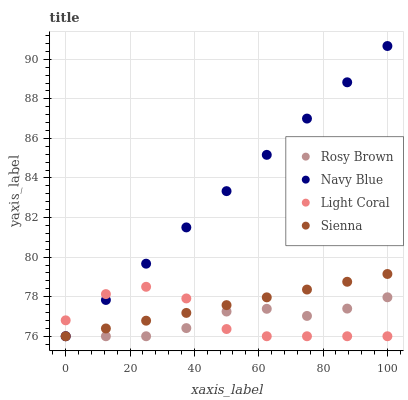Does Rosy Brown have the minimum area under the curve?
Answer yes or no. Yes. Does Navy Blue have the maximum area under the curve?
Answer yes or no. Yes. Does Navy Blue have the minimum area under the curve?
Answer yes or no. No. Does Rosy Brown have the maximum area under the curve?
Answer yes or no. No. Is Sienna the smoothest?
Answer yes or no. Yes. Is Light Coral the roughest?
Answer yes or no. Yes. Is Navy Blue the smoothest?
Answer yes or no. No. Is Navy Blue the roughest?
Answer yes or no. No. Does Light Coral have the lowest value?
Answer yes or no. Yes. Does Navy Blue have the highest value?
Answer yes or no. Yes. Does Rosy Brown have the highest value?
Answer yes or no. No. Does Navy Blue intersect Light Coral?
Answer yes or no. Yes. Is Navy Blue less than Light Coral?
Answer yes or no. No. Is Navy Blue greater than Light Coral?
Answer yes or no. No. 